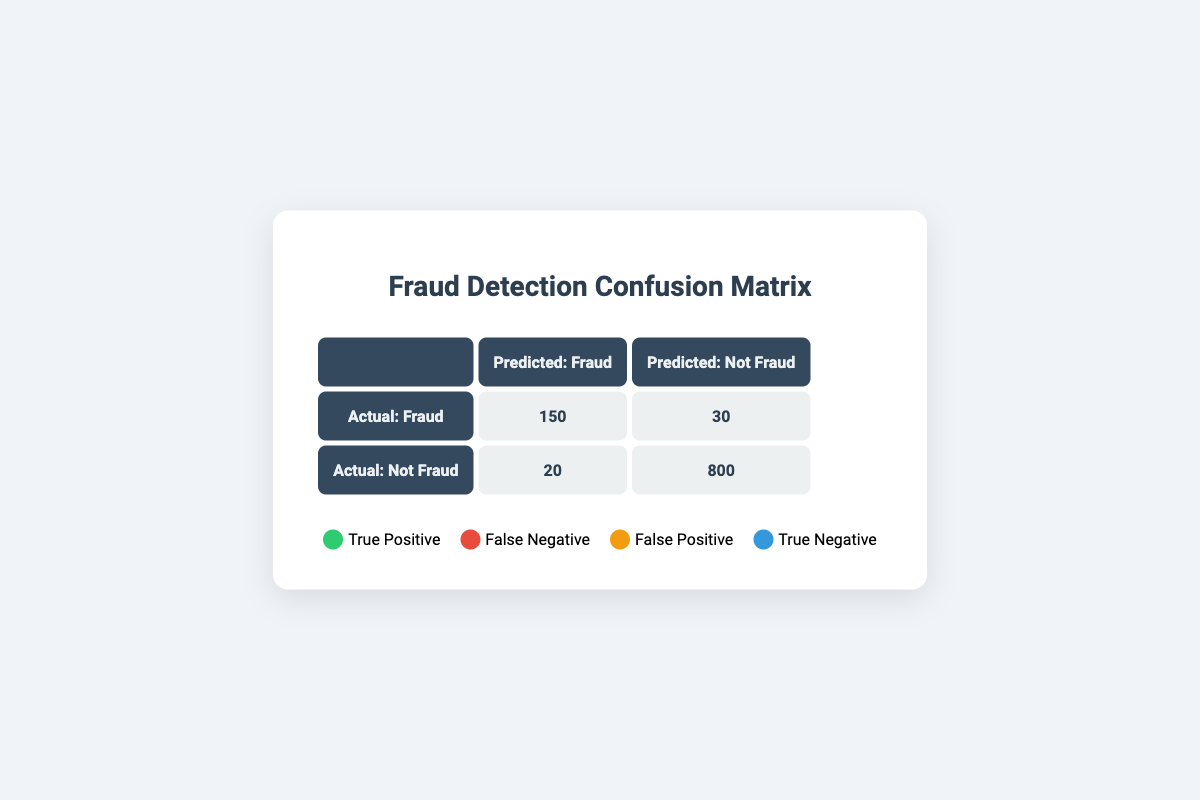What is the number of true positives in the confusion matrix? The true positives are those cases where the actual class was Fraud, and the model also predicted Fraud. In the matrix, this value is directly shown in the cell at the intersection of Actual: Fraud and Predicted: Fraud, which is 150.
Answer: 150 How many false negatives are reported in the matrix? False negatives are the instances where the actual class was Fraud, but the model predicted Not Fraud. This value can be found in the intersection of Actual: Fraud and Predicted: Not Fraud, which is given as 30.
Answer: 30 What is the total number of actual Fraud cases? To find the total actual Fraud cases, we add the true positives (150) to the false negatives (30). Therefore, Total Actual Fraud = 150 + 30 = 180.
Answer: 180 Is the number of true negatives greater than the number of false positives? True negatives are the instances where the actual class was Not Fraud, and the model predicted Not Fraud, which is 800. False positives are where the actual class was Not Fraud, but the model predicted Fraud, which is 20. Since 800 is greater than 20, the answer is yes.
Answer: Yes What percentage of the total predictions were correctly identified as Not Fraud? The total predictions can be calculated by adding all values in the matrix: 150 + 30 + 20 + 800 = 1000. The correctly identified Not Fraud cases (true negatives) is 800. Therefore, the percentage is calculated as (800/1000) * 100 = 80%.
Answer: 80% What is the total of false predictions in the dataset? False predictions consist of false negatives (30) and false positives (20). Adding these gives us the total of false predictions: 30 + 20 = 50.
Answer: 50 How many more true negatives are there compared to true positives? The number of true negatives is 800 and the number of true positives is 150. The difference is calculated as 800 - 150 = 650.
Answer: 650 What fraction of cases predicted as Fraud were actually Fraud? The number of cases predicted as Fraud includes true positives (150) and false positives (20), giving us 150 + 20 = 170. The fraction that were actually Fraud would be the true positives divided by the total predicted as Fraud: 150/170, which simplifies to approximately 0.882 or 88.2%.
Answer: 88.2% What is the total count of Not Fraud cases predicted by the model? To find the total predicted as Not Fraud, we need to add false negatives (30) and true negatives (800). So, Total Predicted Not Fraud = 30 + 800 = 830.
Answer: 830 